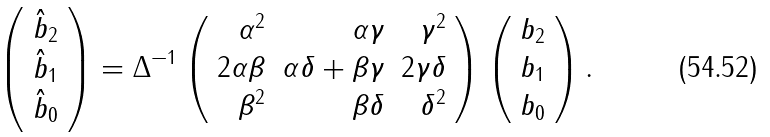<formula> <loc_0><loc_0><loc_500><loc_500>\left ( \begin{array} { r } \hat { b } _ { 2 } \\ \hat { b } _ { 1 } \\ \hat { b } _ { 0 } \end{array} \right ) = \Delta ^ { - 1 } \left ( \begin{array} { r r r } \alpha ^ { 2 } & \alpha \gamma & \gamma ^ { 2 } \\ 2 \alpha \beta & \alpha \delta + \beta \gamma & 2 \gamma \delta \\ \beta ^ { 2 } & \beta \delta & \delta ^ { 2 } \end{array} \right ) \left ( \begin{array} { r } b _ { 2 } \\ b _ { 1 } \\ b _ { 0 } \end{array} \right ) .</formula> 